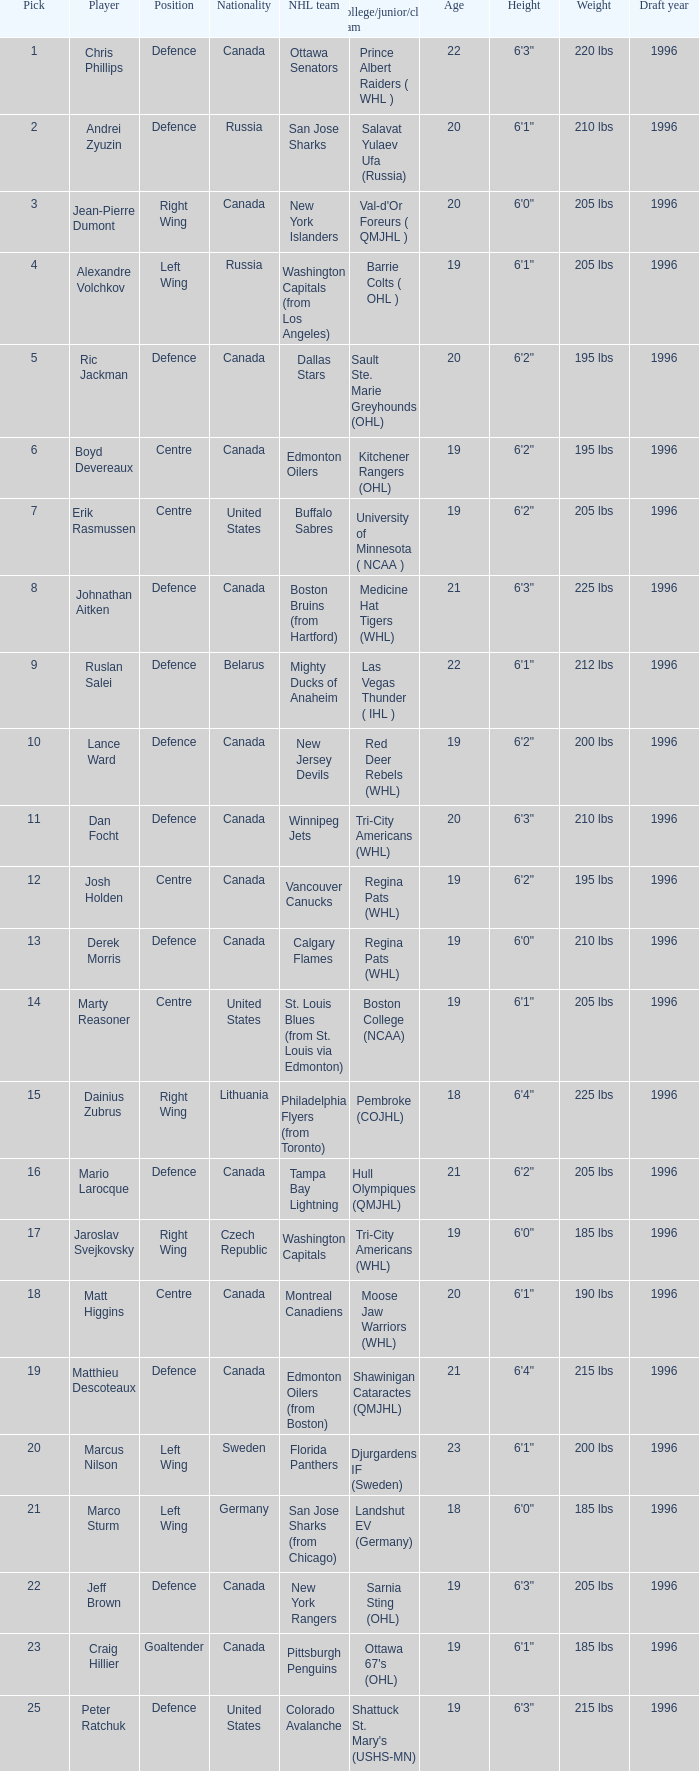How many positions does the draft pick whose nationality is Czech Republic play? 1.0. 